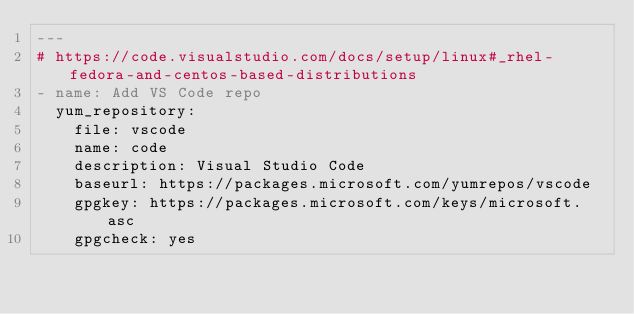Convert code to text. <code><loc_0><loc_0><loc_500><loc_500><_YAML_>---
# https://code.visualstudio.com/docs/setup/linux#_rhel-fedora-and-centos-based-distributions
- name: Add VS Code repo
  yum_repository:
    file: vscode
    name: code
    description: Visual Studio Code
    baseurl: https://packages.microsoft.com/yumrepos/vscode
    gpgkey: https://packages.microsoft.com/keys/microsoft.asc
    gpgcheck: yes
</code> 